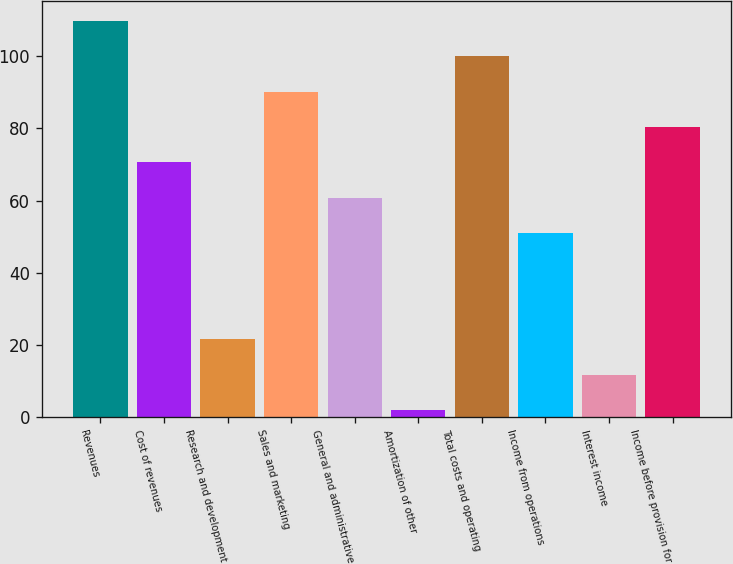<chart> <loc_0><loc_0><loc_500><loc_500><bar_chart><fcel>Revenues<fcel>Cost of revenues<fcel>Research and development<fcel>Sales and marketing<fcel>General and administrative<fcel>Amortization of other<fcel>Total costs and operating<fcel>Income from operations<fcel>Interest income<fcel>Income before provision for<nl><fcel>109.8<fcel>70.6<fcel>21.6<fcel>90.2<fcel>60.8<fcel>2<fcel>100<fcel>51<fcel>11.8<fcel>80.4<nl></chart> 